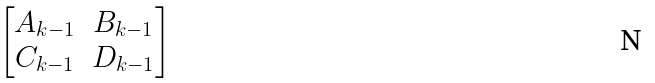Convert formula to latex. <formula><loc_0><loc_0><loc_500><loc_500>\begin{bmatrix} A _ { k - 1 } & B _ { k - 1 } \\ C _ { k - 1 } & D _ { k - 1 } \end{bmatrix}</formula> 